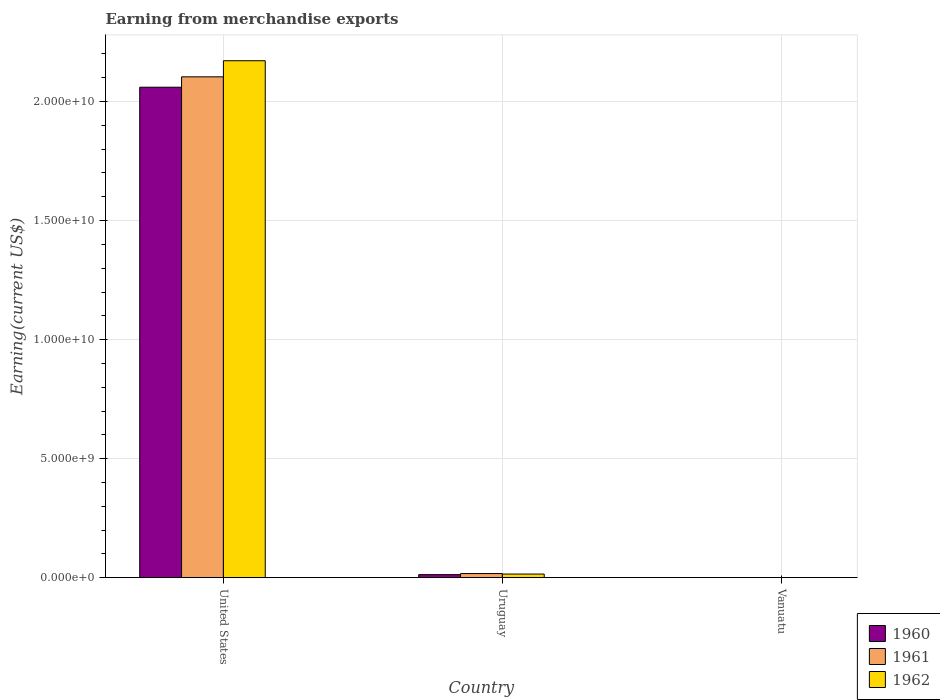How many groups of bars are there?
Your response must be concise. 3. Are the number of bars per tick equal to the number of legend labels?
Your answer should be compact. Yes. How many bars are there on the 2nd tick from the left?
Your response must be concise. 3. What is the label of the 1st group of bars from the left?
Your answer should be compact. United States. In how many cases, is the number of bars for a given country not equal to the number of legend labels?
Ensure brevity in your answer.  0. What is the amount earned from merchandise exports in 1960 in Uruguay?
Keep it short and to the point. 1.29e+08. Across all countries, what is the maximum amount earned from merchandise exports in 1960?
Offer a very short reply. 2.06e+1. Across all countries, what is the minimum amount earned from merchandise exports in 1962?
Provide a succinct answer. 5.52e+06. In which country was the amount earned from merchandise exports in 1962 minimum?
Offer a terse response. Vanuatu. What is the total amount earned from merchandise exports in 1962 in the graph?
Ensure brevity in your answer.  2.19e+1. What is the difference between the amount earned from merchandise exports in 1961 in United States and that in Vanuatu?
Your answer should be compact. 2.10e+1. What is the difference between the amount earned from merchandise exports in 1962 in Uruguay and the amount earned from merchandise exports in 1961 in United States?
Give a very brief answer. -2.09e+1. What is the average amount earned from merchandise exports in 1961 per country?
Your answer should be compact. 7.07e+09. What is the difference between the amount earned from merchandise exports of/in 1960 and amount earned from merchandise exports of/in 1962 in Uruguay?
Make the answer very short. -2.40e+07. In how many countries, is the amount earned from merchandise exports in 1962 greater than 6000000000 US$?
Offer a terse response. 1. What is the ratio of the amount earned from merchandise exports in 1962 in Uruguay to that in Vanuatu?
Make the answer very short. 27.79. What is the difference between the highest and the second highest amount earned from merchandise exports in 1961?
Provide a short and direct response. 2.09e+1. What is the difference between the highest and the lowest amount earned from merchandise exports in 1961?
Provide a short and direct response. 2.10e+1. In how many countries, is the amount earned from merchandise exports in 1960 greater than the average amount earned from merchandise exports in 1960 taken over all countries?
Ensure brevity in your answer.  1. Is the sum of the amount earned from merchandise exports in 1960 in Uruguay and Vanuatu greater than the maximum amount earned from merchandise exports in 1962 across all countries?
Your answer should be very brief. No. Is it the case that in every country, the sum of the amount earned from merchandise exports in 1960 and amount earned from merchandise exports in 1961 is greater than the amount earned from merchandise exports in 1962?
Offer a terse response. Yes. Does the graph contain any zero values?
Ensure brevity in your answer.  No. How many legend labels are there?
Offer a very short reply. 3. How are the legend labels stacked?
Your answer should be very brief. Vertical. What is the title of the graph?
Provide a short and direct response. Earning from merchandise exports. What is the label or title of the X-axis?
Your response must be concise. Country. What is the label or title of the Y-axis?
Make the answer very short. Earning(current US$). What is the Earning(current US$) in 1960 in United States?
Give a very brief answer. 2.06e+1. What is the Earning(current US$) in 1961 in United States?
Provide a succinct answer. 2.10e+1. What is the Earning(current US$) in 1962 in United States?
Ensure brevity in your answer.  2.17e+1. What is the Earning(current US$) of 1960 in Uruguay?
Ensure brevity in your answer.  1.29e+08. What is the Earning(current US$) in 1961 in Uruguay?
Provide a short and direct response. 1.75e+08. What is the Earning(current US$) of 1962 in Uruguay?
Make the answer very short. 1.53e+08. What is the Earning(current US$) of 1960 in Vanuatu?
Give a very brief answer. 4.78e+06. What is the Earning(current US$) in 1961 in Vanuatu?
Your answer should be very brief. 4.73e+06. What is the Earning(current US$) in 1962 in Vanuatu?
Your response must be concise. 5.52e+06. Across all countries, what is the maximum Earning(current US$) of 1960?
Ensure brevity in your answer.  2.06e+1. Across all countries, what is the maximum Earning(current US$) of 1961?
Keep it short and to the point. 2.10e+1. Across all countries, what is the maximum Earning(current US$) of 1962?
Make the answer very short. 2.17e+1. Across all countries, what is the minimum Earning(current US$) in 1960?
Provide a short and direct response. 4.78e+06. Across all countries, what is the minimum Earning(current US$) of 1961?
Your response must be concise. 4.73e+06. Across all countries, what is the minimum Earning(current US$) in 1962?
Give a very brief answer. 5.52e+06. What is the total Earning(current US$) in 1960 in the graph?
Make the answer very short. 2.07e+1. What is the total Earning(current US$) of 1961 in the graph?
Give a very brief answer. 2.12e+1. What is the total Earning(current US$) in 1962 in the graph?
Ensure brevity in your answer.  2.19e+1. What is the difference between the Earning(current US$) of 1960 in United States and that in Uruguay?
Your response must be concise. 2.05e+1. What is the difference between the Earning(current US$) of 1961 in United States and that in Uruguay?
Ensure brevity in your answer.  2.09e+1. What is the difference between the Earning(current US$) of 1962 in United States and that in Uruguay?
Keep it short and to the point. 2.16e+1. What is the difference between the Earning(current US$) in 1960 in United States and that in Vanuatu?
Give a very brief answer. 2.06e+1. What is the difference between the Earning(current US$) in 1961 in United States and that in Vanuatu?
Offer a very short reply. 2.10e+1. What is the difference between the Earning(current US$) in 1962 in United States and that in Vanuatu?
Your response must be concise. 2.17e+1. What is the difference between the Earning(current US$) in 1960 in Uruguay and that in Vanuatu?
Your answer should be compact. 1.25e+08. What is the difference between the Earning(current US$) of 1961 in Uruguay and that in Vanuatu?
Your answer should be very brief. 1.70e+08. What is the difference between the Earning(current US$) of 1962 in Uruguay and that in Vanuatu?
Provide a succinct answer. 1.48e+08. What is the difference between the Earning(current US$) of 1960 in United States and the Earning(current US$) of 1961 in Uruguay?
Provide a short and direct response. 2.04e+1. What is the difference between the Earning(current US$) of 1960 in United States and the Earning(current US$) of 1962 in Uruguay?
Your answer should be compact. 2.04e+1. What is the difference between the Earning(current US$) of 1961 in United States and the Earning(current US$) of 1962 in Uruguay?
Ensure brevity in your answer.  2.09e+1. What is the difference between the Earning(current US$) in 1960 in United States and the Earning(current US$) in 1961 in Vanuatu?
Ensure brevity in your answer.  2.06e+1. What is the difference between the Earning(current US$) of 1960 in United States and the Earning(current US$) of 1962 in Vanuatu?
Provide a short and direct response. 2.06e+1. What is the difference between the Earning(current US$) of 1961 in United States and the Earning(current US$) of 1962 in Vanuatu?
Offer a very short reply. 2.10e+1. What is the difference between the Earning(current US$) of 1960 in Uruguay and the Earning(current US$) of 1961 in Vanuatu?
Offer a very short reply. 1.25e+08. What is the difference between the Earning(current US$) in 1960 in Uruguay and the Earning(current US$) in 1962 in Vanuatu?
Provide a short and direct response. 1.24e+08. What is the difference between the Earning(current US$) of 1961 in Uruguay and the Earning(current US$) of 1962 in Vanuatu?
Your answer should be very brief. 1.69e+08. What is the average Earning(current US$) in 1960 per country?
Give a very brief answer. 6.91e+09. What is the average Earning(current US$) of 1961 per country?
Your answer should be very brief. 7.07e+09. What is the average Earning(current US$) in 1962 per country?
Keep it short and to the point. 7.29e+09. What is the difference between the Earning(current US$) of 1960 and Earning(current US$) of 1961 in United States?
Provide a succinct answer. -4.36e+08. What is the difference between the Earning(current US$) of 1960 and Earning(current US$) of 1962 in United States?
Your response must be concise. -1.11e+09. What is the difference between the Earning(current US$) of 1961 and Earning(current US$) of 1962 in United States?
Provide a short and direct response. -6.77e+08. What is the difference between the Earning(current US$) of 1960 and Earning(current US$) of 1961 in Uruguay?
Your response must be concise. -4.53e+07. What is the difference between the Earning(current US$) in 1960 and Earning(current US$) in 1962 in Uruguay?
Your response must be concise. -2.40e+07. What is the difference between the Earning(current US$) in 1961 and Earning(current US$) in 1962 in Uruguay?
Give a very brief answer. 2.13e+07. What is the difference between the Earning(current US$) in 1960 and Earning(current US$) in 1961 in Vanuatu?
Make the answer very short. 5.01e+04. What is the difference between the Earning(current US$) in 1960 and Earning(current US$) in 1962 in Vanuatu?
Ensure brevity in your answer.  -7.43e+05. What is the difference between the Earning(current US$) of 1961 and Earning(current US$) of 1962 in Vanuatu?
Keep it short and to the point. -7.93e+05. What is the ratio of the Earning(current US$) of 1960 in United States to that in Uruguay?
Offer a very short reply. 159.2. What is the ratio of the Earning(current US$) of 1961 in United States to that in Uruguay?
Ensure brevity in your answer.  120.4. What is the ratio of the Earning(current US$) of 1962 in United States to that in Uruguay?
Your response must be concise. 141.52. What is the ratio of the Earning(current US$) in 1960 in United States to that in Vanuatu?
Provide a succinct answer. 4311.61. What is the ratio of the Earning(current US$) in 1961 in United States to that in Vanuatu?
Give a very brief answer. 4449.54. What is the ratio of the Earning(current US$) in 1962 in United States to that in Vanuatu?
Keep it short and to the point. 3932.93. What is the ratio of the Earning(current US$) in 1960 in Uruguay to that in Vanuatu?
Your answer should be very brief. 27.08. What is the ratio of the Earning(current US$) in 1961 in Uruguay to that in Vanuatu?
Your answer should be compact. 36.96. What is the ratio of the Earning(current US$) of 1962 in Uruguay to that in Vanuatu?
Offer a very short reply. 27.79. What is the difference between the highest and the second highest Earning(current US$) in 1960?
Ensure brevity in your answer.  2.05e+1. What is the difference between the highest and the second highest Earning(current US$) of 1961?
Provide a succinct answer. 2.09e+1. What is the difference between the highest and the second highest Earning(current US$) in 1962?
Offer a very short reply. 2.16e+1. What is the difference between the highest and the lowest Earning(current US$) in 1960?
Provide a short and direct response. 2.06e+1. What is the difference between the highest and the lowest Earning(current US$) of 1961?
Provide a succinct answer. 2.10e+1. What is the difference between the highest and the lowest Earning(current US$) in 1962?
Offer a terse response. 2.17e+1. 